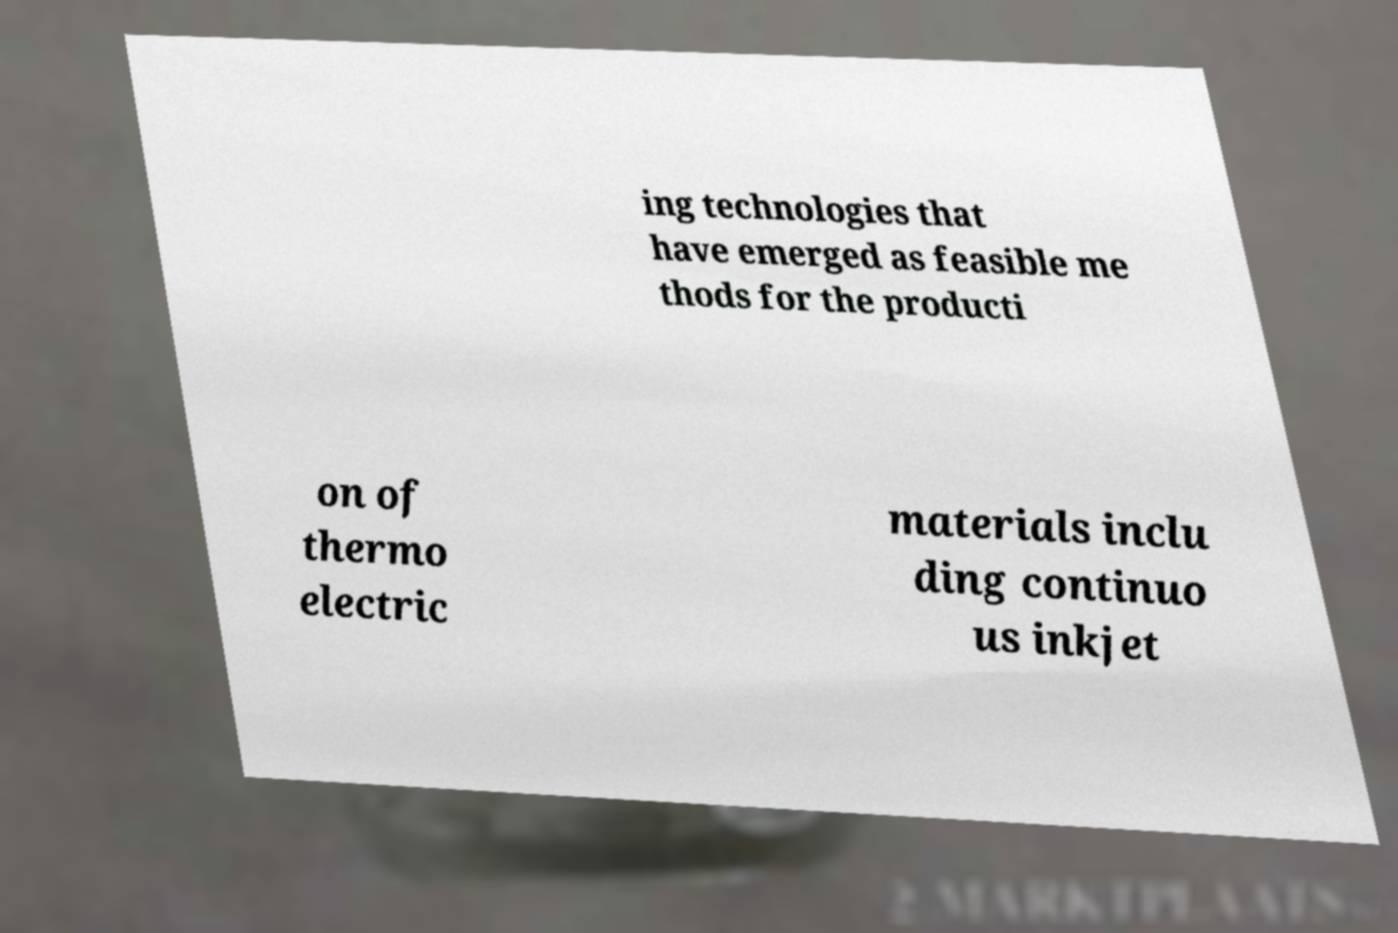Can you read and provide the text displayed in the image?This photo seems to have some interesting text. Can you extract and type it out for me? ing technologies that have emerged as feasible me thods for the producti on of thermo electric materials inclu ding continuo us inkjet 